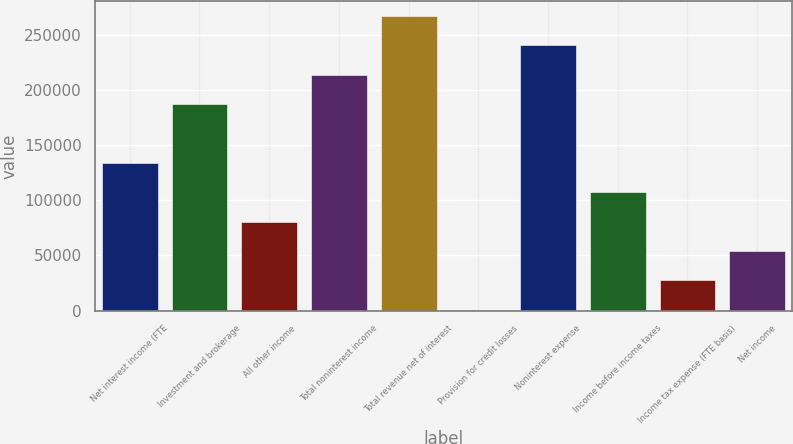Convert chart to OTSL. <chart><loc_0><loc_0><loc_500><loc_500><bar_chart><fcel>Net interest income (FTE<fcel>Investment and brokerage<fcel>All other income<fcel>Total noninterest income<fcel>Total revenue net of interest<fcel>Provision for credit losses<fcel>Noninterest expense<fcel>Income before income taxes<fcel>Income tax expense (FTE basis)<fcel>Net income<nl><fcel>133904<fcel>187208<fcel>80601.1<fcel>213860<fcel>267163<fcel>646<fcel>240511<fcel>107253<fcel>27297.7<fcel>53949.4<nl></chart> 